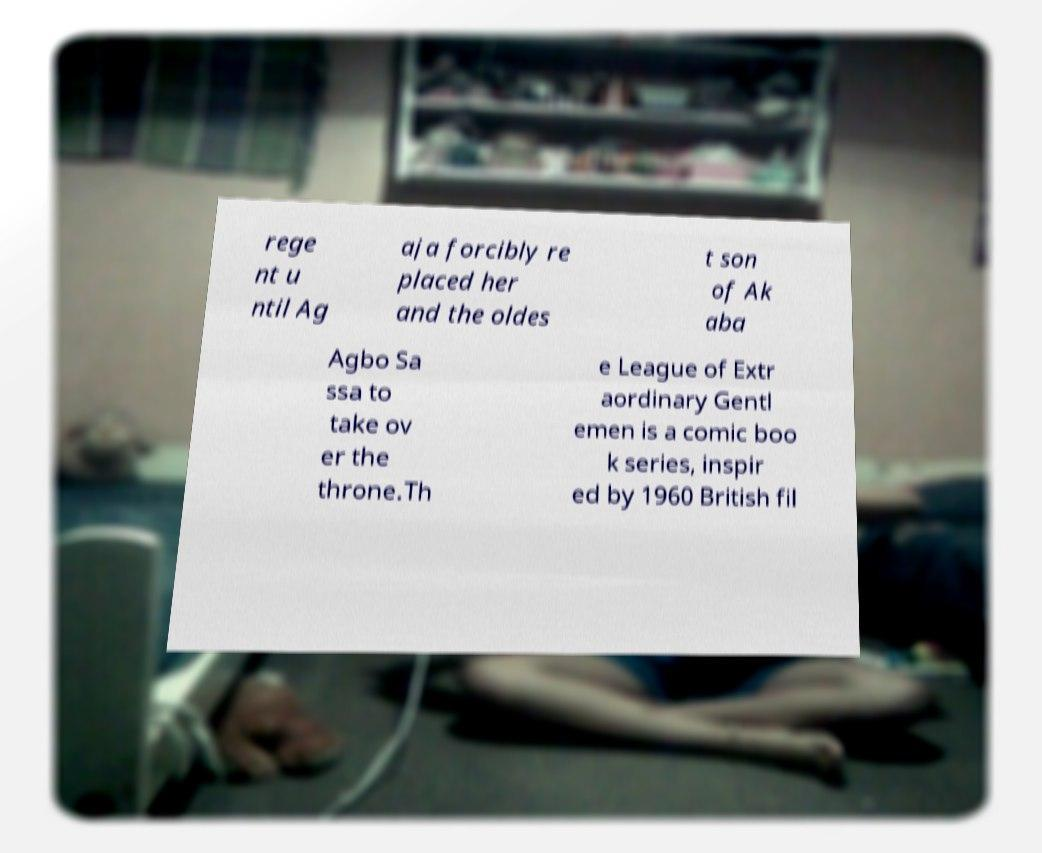Can you accurately transcribe the text from the provided image for me? rege nt u ntil Ag aja forcibly re placed her and the oldes t son of Ak aba Agbo Sa ssa to take ov er the throne.Th e League of Extr aordinary Gentl emen is a comic boo k series, inspir ed by 1960 British fil 